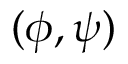<formula> <loc_0><loc_0><loc_500><loc_500>( \phi , \psi )</formula> 